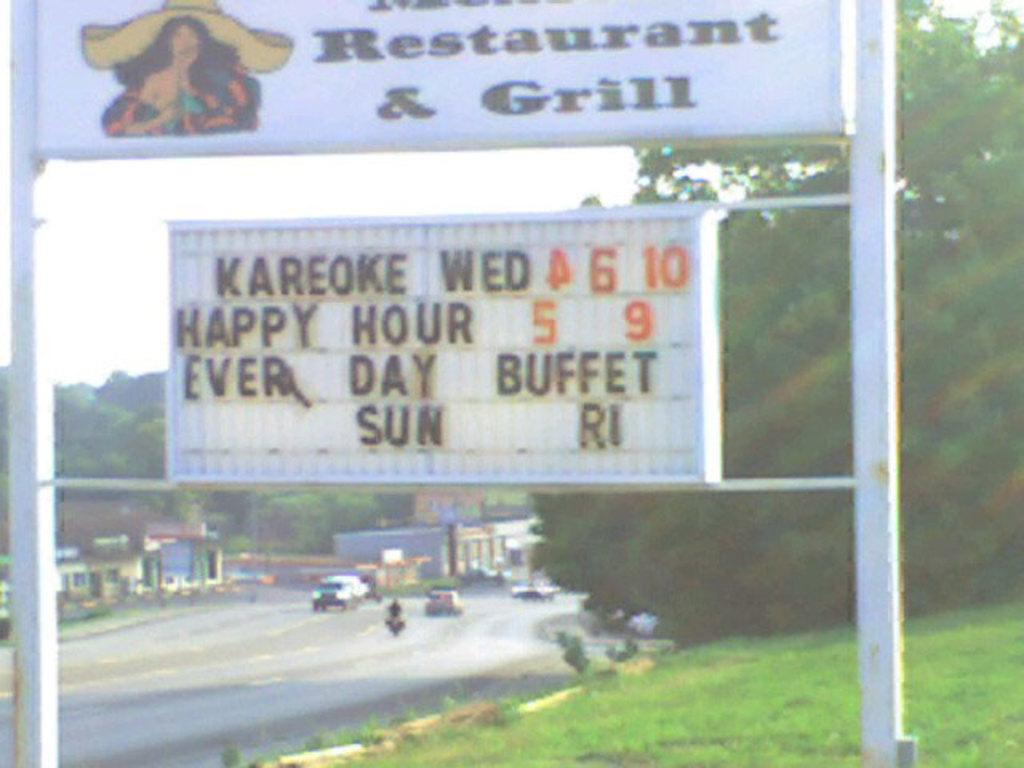<image>
Relay a brief, clear account of the picture shown. a white sign with Restaurant and Grill written on it 